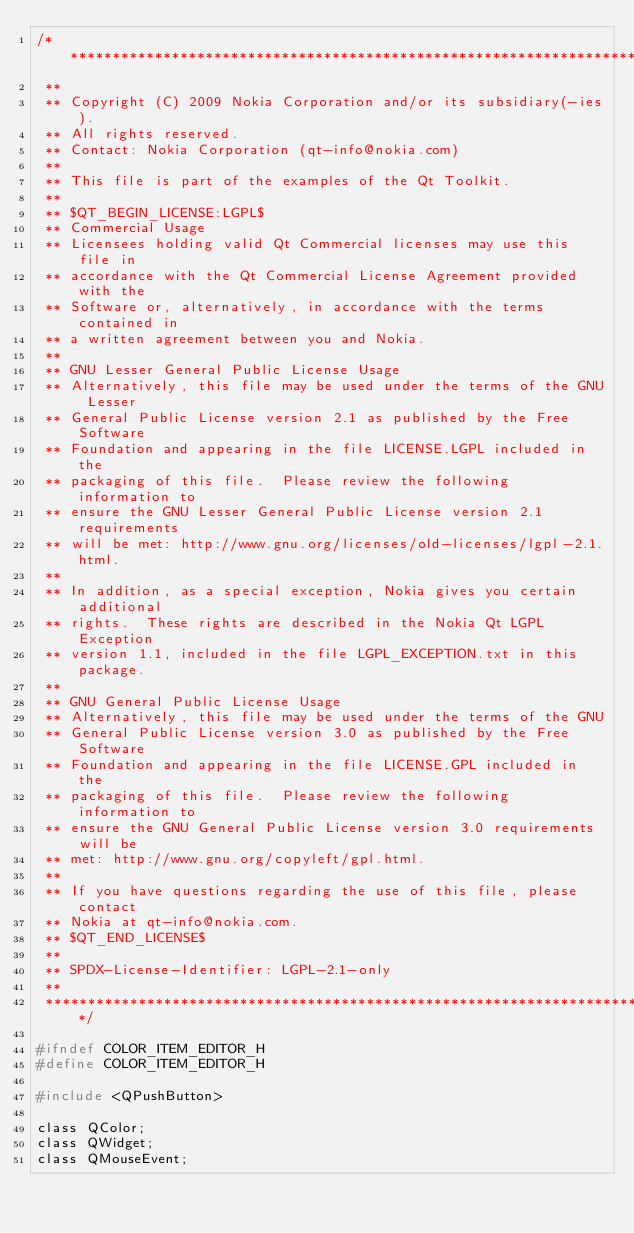<code> <loc_0><loc_0><loc_500><loc_500><_C_>/****************************************************************************
 **
 ** Copyright (C) 2009 Nokia Corporation and/or its subsidiary(-ies).
 ** All rights reserved.
 ** Contact: Nokia Corporation (qt-info@nokia.com)
 **
 ** This file is part of the examples of the Qt Toolkit.
 **
 ** $QT_BEGIN_LICENSE:LGPL$
 ** Commercial Usage
 ** Licensees holding valid Qt Commercial licenses may use this file in
 ** accordance with the Qt Commercial License Agreement provided with the
 ** Software or, alternatively, in accordance with the terms contained in
 ** a written agreement between you and Nokia.
 **
 ** GNU Lesser General Public License Usage
 ** Alternatively, this file may be used under the terms of the GNU Lesser
 ** General Public License version 2.1 as published by the Free Software
 ** Foundation and appearing in the file LICENSE.LGPL included in the
 ** packaging of this file.  Please review the following information to
 ** ensure the GNU Lesser General Public License version 2.1 requirements
 ** will be met: http://www.gnu.org/licenses/old-licenses/lgpl-2.1.html.
 **
 ** In addition, as a special exception, Nokia gives you certain additional
 ** rights.  These rights are described in the Nokia Qt LGPL Exception
 ** version 1.1, included in the file LGPL_EXCEPTION.txt in this package.
 **
 ** GNU General Public License Usage
 ** Alternatively, this file may be used under the terms of the GNU
 ** General Public License version 3.0 as published by the Free Software
 ** Foundation and appearing in the file LICENSE.GPL included in the
 ** packaging of this file.  Please review the following information to
 ** ensure the GNU General Public License version 3.0 requirements will be
 ** met: http://www.gnu.org/copyleft/gpl.html.
 **
 ** If you have questions regarding the use of this file, please contact
 ** Nokia at qt-info@nokia.com.
 ** $QT_END_LICENSE$
 **
 ** SPDX-License-Identifier: LGPL-2.1-only
 **
 ****************************************************************************/

#ifndef COLOR_ITEM_EDITOR_H
#define COLOR_ITEM_EDITOR_H

#include <QPushButton>

class QColor;
class QWidget;
class QMouseEvent;
</code> 